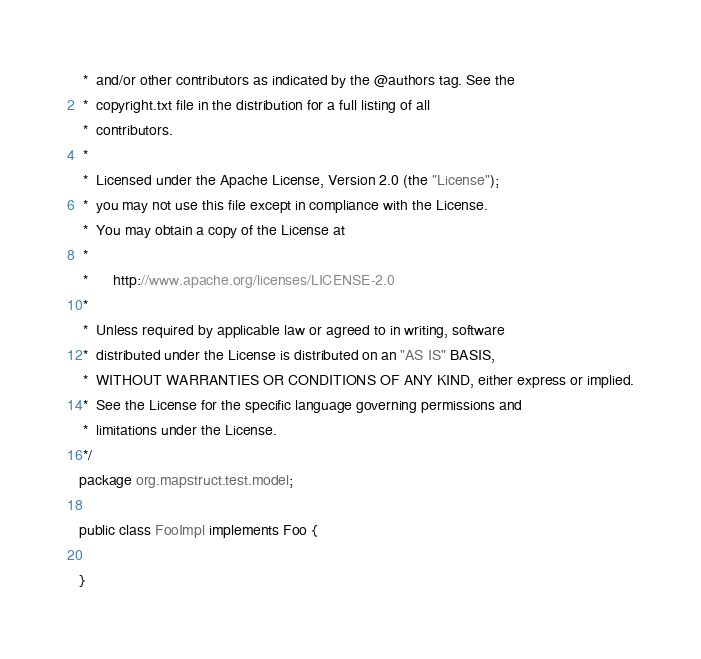Convert code to text. <code><loc_0><loc_0><loc_500><loc_500><_Java_> *  and/or other contributors as indicated by the @authors tag. See the
 *  copyright.txt file in the distribution for a full listing of all
 *  contributors.
 *
 *  Licensed under the Apache License, Version 2.0 (the "License");
 *  you may not use this file except in compliance with the License.
 *  You may obtain a copy of the License at
 *
 *      http://www.apache.org/licenses/LICENSE-2.0
 *
 *  Unless required by applicable law or agreed to in writing, software
 *  distributed under the License is distributed on an "AS IS" BASIS,
 *  WITHOUT WARRANTIES OR CONDITIONS OF ANY KIND, either express or implied.
 *  See the License for the specific language governing permissions and
 *  limitations under the License.
 */
package org.mapstruct.test.model;

public class FooImpl implements Foo {

}
</code> 